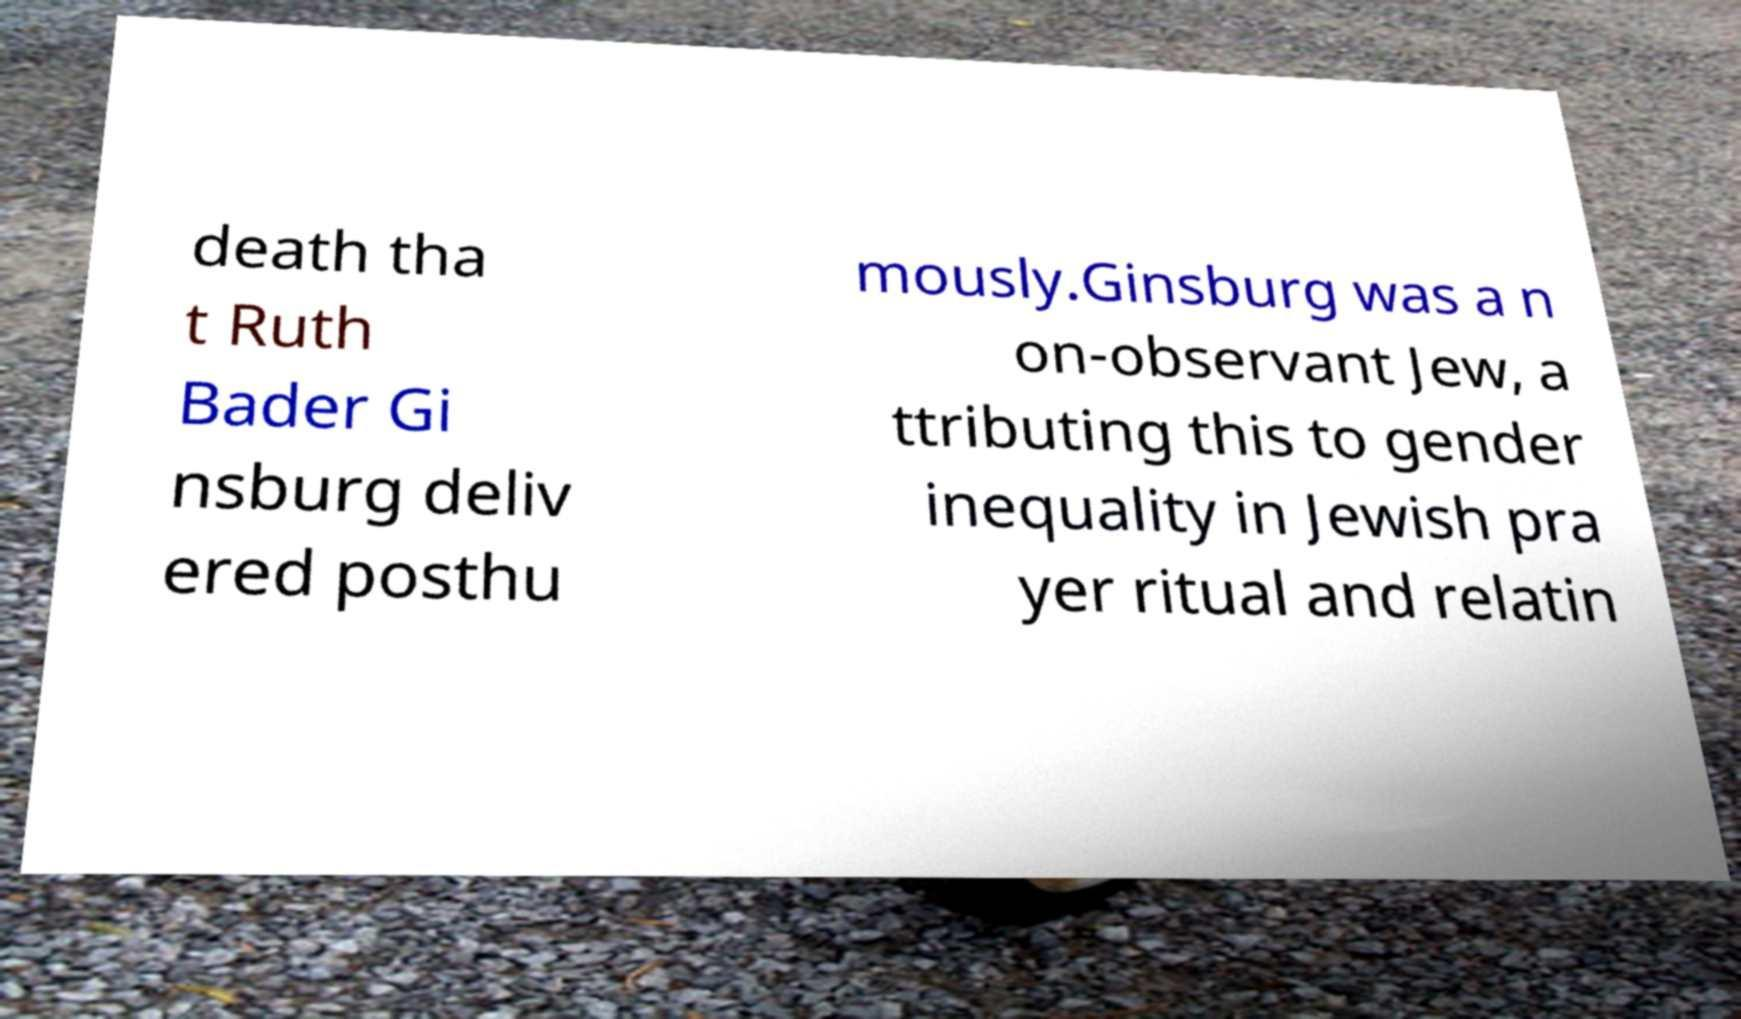Can you read and provide the text displayed in the image?This photo seems to have some interesting text. Can you extract and type it out for me? death tha t Ruth Bader Gi nsburg deliv ered posthu mously.Ginsburg was a n on-observant Jew, a ttributing this to gender inequality in Jewish pra yer ritual and relatin 